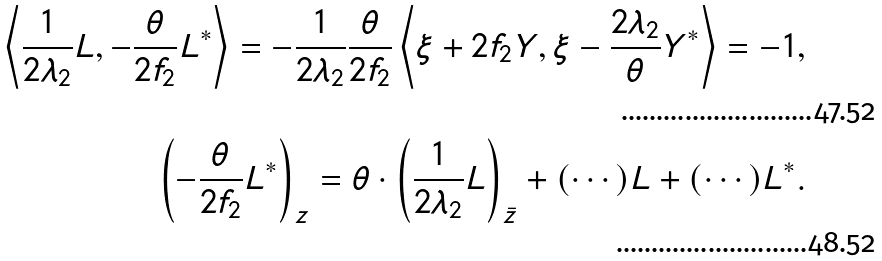Convert formula to latex. <formula><loc_0><loc_0><loc_500><loc_500>\left \langle \frac { 1 } { 2 \lambda _ { 2 } } L , - \frac { \theta } { 2 f _ { 2 } } L ^ { \ast } \right \rangle = - \frac { 1 } { 2 \lambda _ { 2 } } \frac { \theta } { 2 f _ { 2 } } \left \langle \xi + 2 f _ { 2 } Y , \xi - \frac { 2 \lambda _ { 2 } } { \theta } Y ^ { \ast } \right \rangle = - 1 , \\ \left ( - \frac { \theta } { 2 f _ { 2 } } L ^ { \ast } \right ) _ { z } = \theta \cdot \left ( \frac { 1 } { 2 \lambda _ { 2 } } L \right ) _ { \bar { z } } + ( \cdots ) L + ( \cdots ) L ^ { \ast } .</formula> 